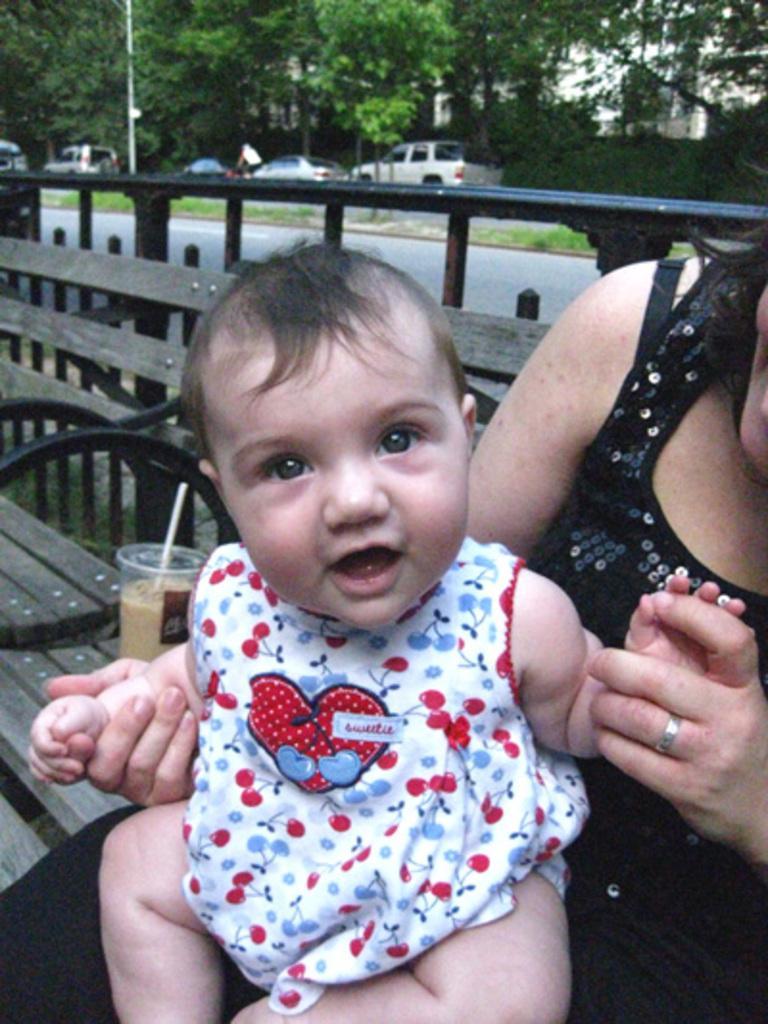Can you describe this image briefly? In this image there is one women sitting on the right side of this image and holding a baby. There is a glass is kept on a table on the left side of this image, and there is a fencing gate in the background. There are some vehicles on the top of this image and there are some trees in the background. 